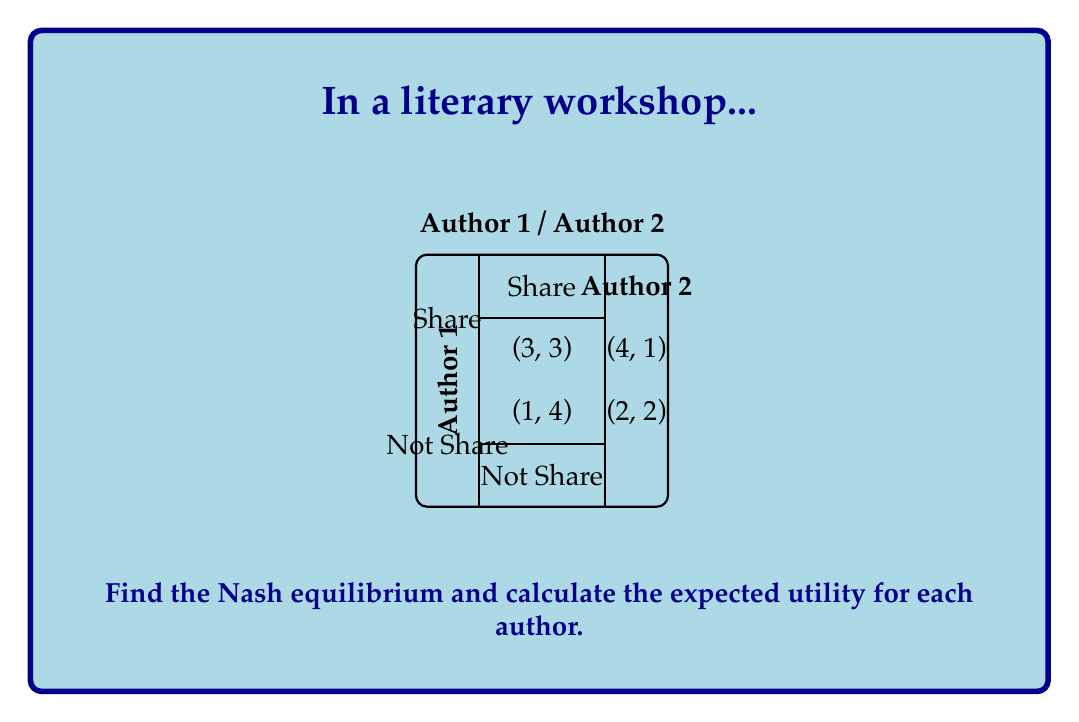Show me your answer to this math problem. To find the Nash equilibrium, we need to analyze each author's best response to the other's strategy:

1. For Author 1:
   - If Author 2 shares, Author 1's best response is to share (3 > 1)
   - If Author 2 doesn't share, Author 1's best response is to share (4 > 2)

2. For Author 2:
   - If Author 1 shares, Author 2's best response is to share (3 > 1)
   - If Author 1 doesn't share, Author 2's best response is to share (4 > 2)

Since both authors' dominant strategy is to share, the Nash equilibrium is (Share, Share).

To calculate the expected utility:

Let $p$ be the probability that Author 1 shares, and $q$ be the probability that Author 2 shares.

Expected utility for Author 1:
$$E_1 = 3pq + 4p(1-q) + 1(1-p)q + 2(1-p)(1-q)$$

Expected utility for Author 2:
$$E_2 = 3pq + 1p(1-q) + 4(1-p)q + 2(1-p)(1-q)$$

At Nash equilibrium (Share, Share), $p = q = 1$:

$$E_1 = E_2 = 3 \cdot 1 \cdot 1 = 3$$
Answer: Nash equilibrium: (Share, Share); Expected utility for each author: 3 